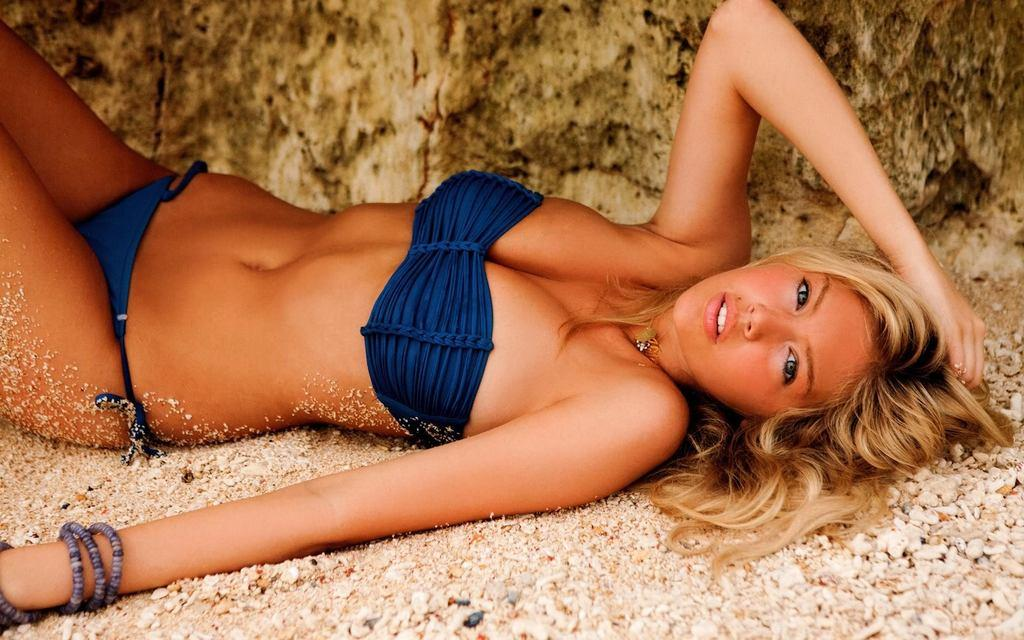Who or what can be seen in the image? There is a person in the image. What is the person doing in the image? The person is laying on the surface of the ground. What type of kite is the person holding in the image? There is no kite present in the image; the person is simply laying on the ground. 